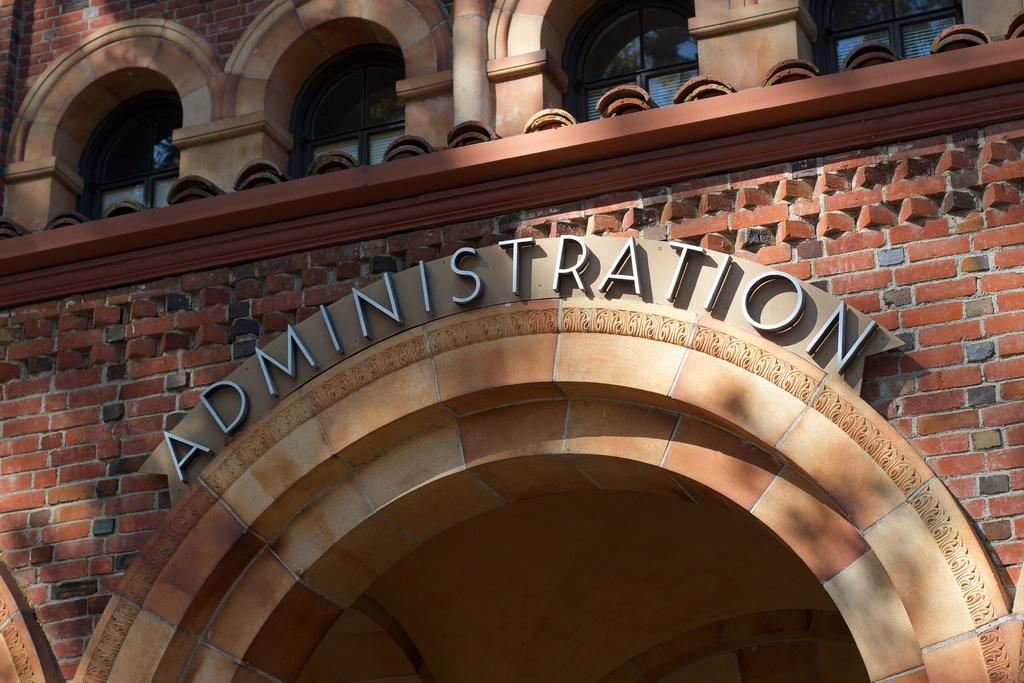What type of structure is visible in the image? There is a building in the image. Can you describe any additional details about the building? There is text written on the building. Is there any quicksand near the building in the image? There is no mention of quicksand in the image, so we cannot determine its presence. 